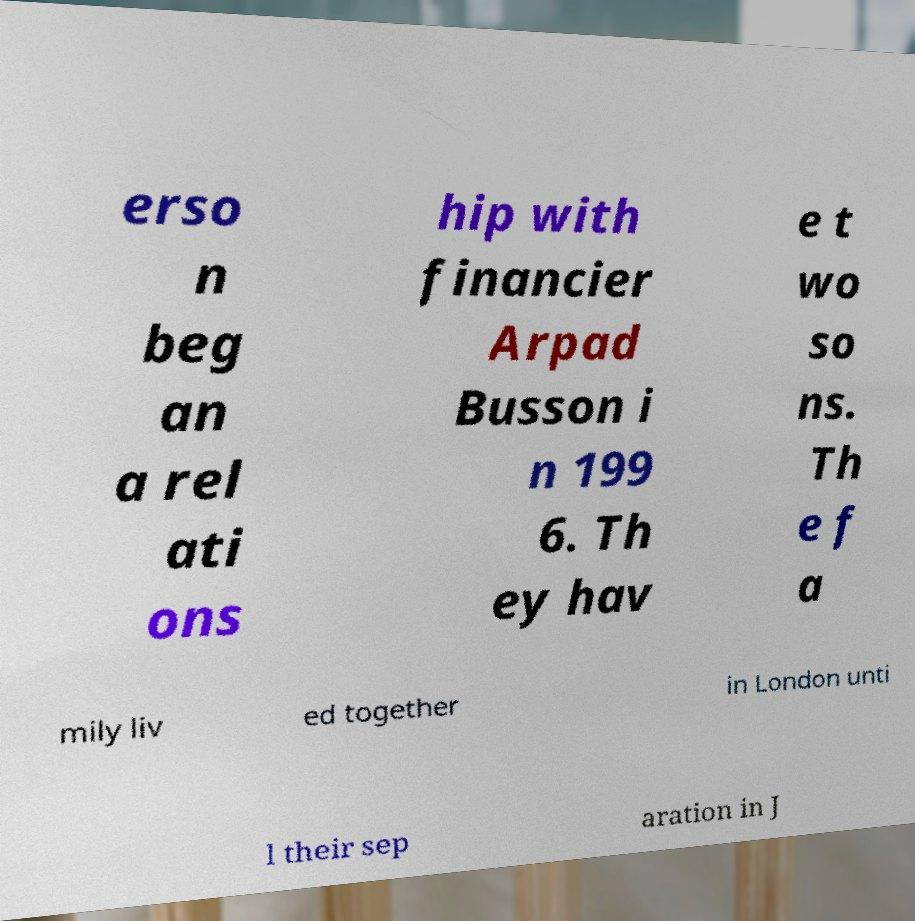What messages or text are displayed in this image? I need them in a readable, typed format. erso n beg an a rel ati ons hip with financier Arpad Busson i n 199 6. Th ey hav e t wo so ns. Th e f a mily liv ed together in London unti l their sep aration in J 